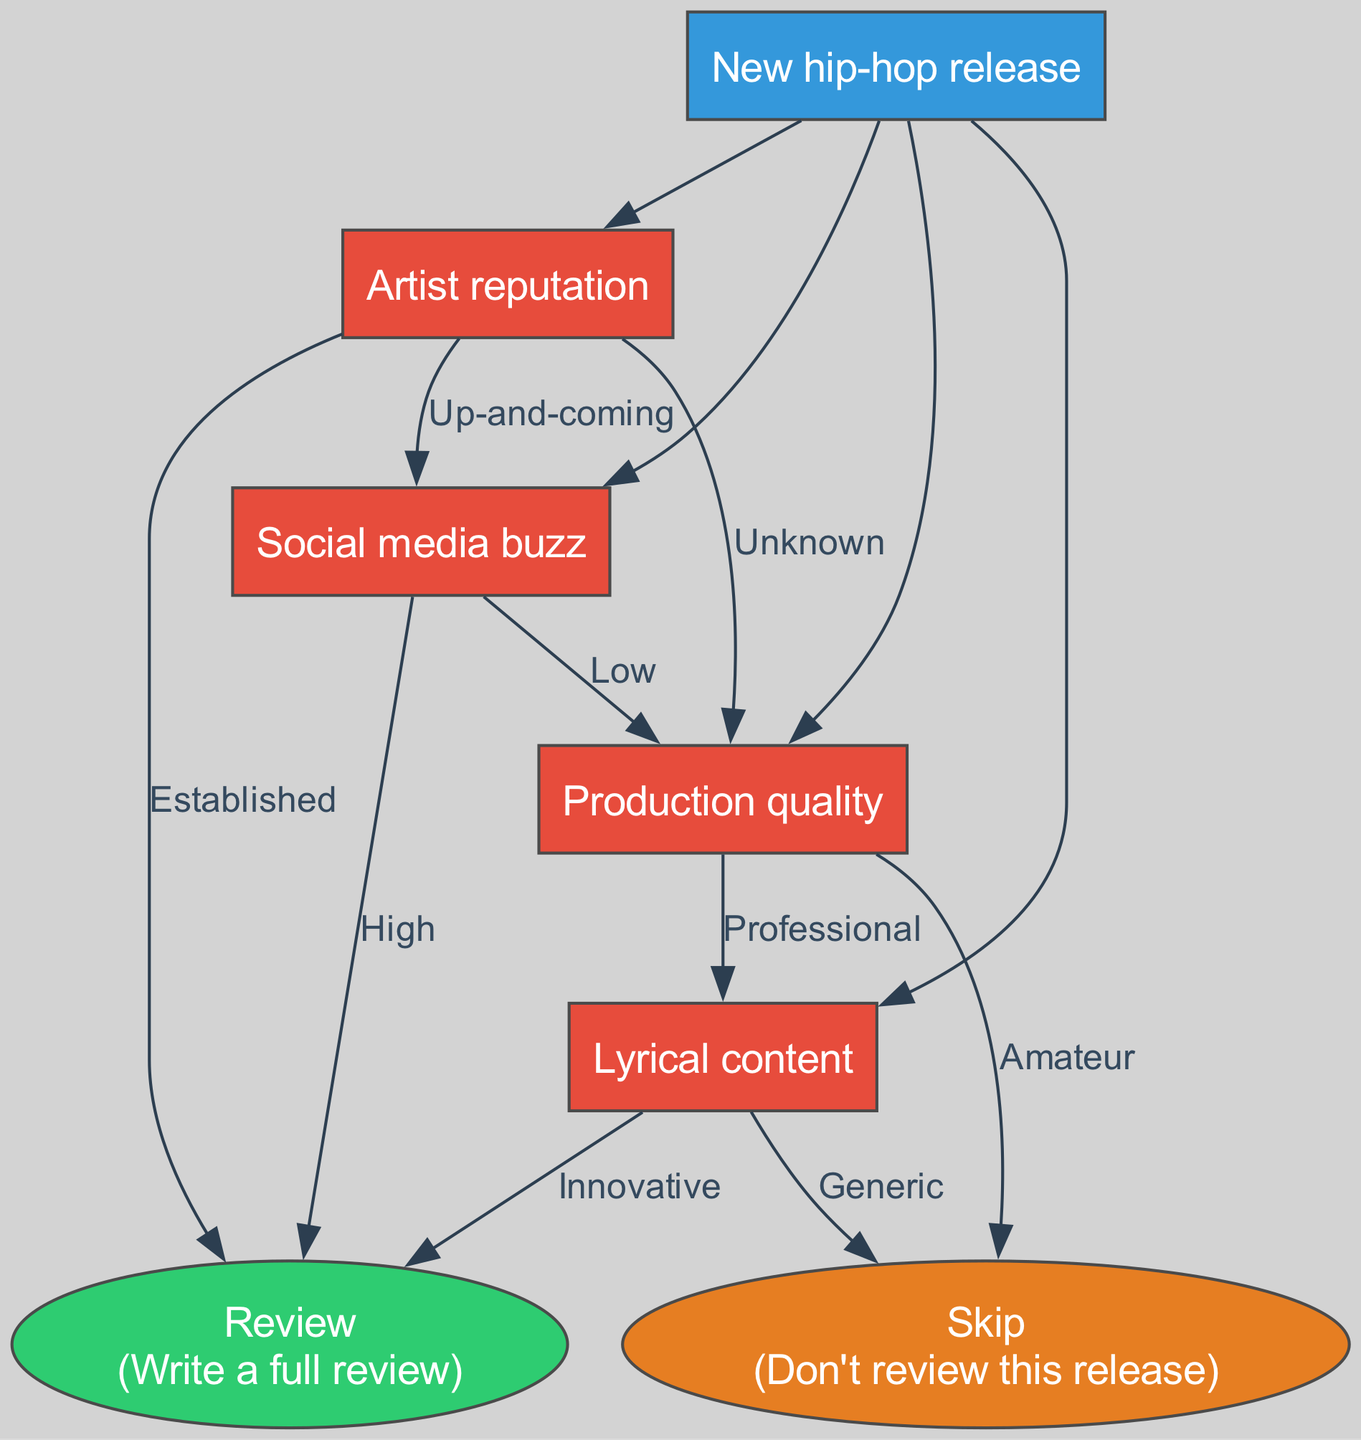What is the root node of the decision tree? The root node is the starting point of the decision tree, which leads to various decisions. According to the diagram, the root node is "New hip-hop release."
Answer: New hip-hop release How many edges are connected to the "Artist reputation" node? To determine the number of edges from the "Artist reputation" node, we count the possible decisions leading from it. There are three edges: "Established," "Up-and-coming," and "Unknown."
Answer: 3 What happens if the production quality is amateur? If the production quality is classified as amateur according to the decision tree, it leads to the "Skip" node. This means that the release will not be reviewed.
Answer: Skip If an artist is unknown and the production quality is professional, what is the next decision? Starting from an unknown artist, we look at the next evaluation step. If the production quality is professional, we then assess the "Lyrical content." Therefore, the next decision is assessed based on lyrical content.
Answer: Lyrical content What is the leaf node that corresponds to a favorable review? The favorable outcome in the decision tree, which indicates that a release is worth reviewing, connects to the "Review" leaf node.
Answer: Review If social media buzz is low, what is the next evaluation factor? When social media buzz is categorized as low, according to the decision tree, it leads us to the next evaluation criterion which is "Production quality."
Answer: Production quality Which node leads directly to skipping the review? In the decision tree, the paths that lead to skipping the review go through either "Production quality" if it is amateur or "Lyrical content" if it is generic. Both paths lead to the "Skip" node.
Answer: Skip What are the possible outcomes if the artist has an established reputation? If the artist has an established reputation, the immediate outcome is to "Review" the release, as there are no further evaluations required.
Answer: Review 